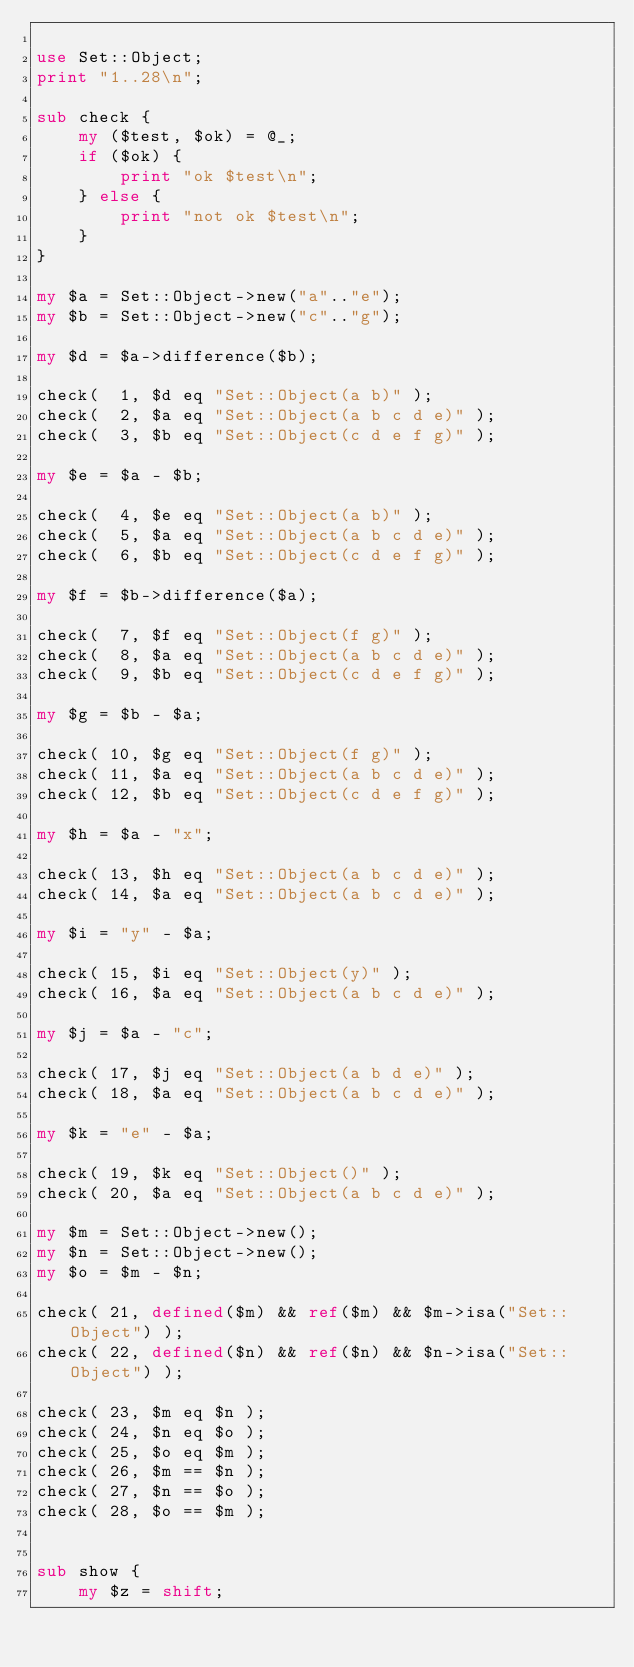Convert code to text. <code><loc_0><loc_0><loc_500><loc_500><_Perl_>
use Set::Object;
print "1..28\n";

sub check {
    my ($test, $ok) = @_;
    if ($ok) {
        print "ok $test\n";
    } else {
        print "not ok $test\n";
    }
}

my $a = Set::Object->new("a".."e");
my $b = Set::Object->new("c".."g");

my $d = $a->difference($b);

check(  1, $d eq "Set::Object(a b)" );
check(  2, $a eq "Set::Object(a b c d e)" );
check(  3, $b eq "Set::Object(c d e f g)" );

my $e = $a - $b;

check(  4, $e eq "Set::Object(a b)" );
check(  5, $a eq "Set::Object(a b c d e)" );
check(  6, $b eq "Set::Object(c d e f g)" );

my $f = $b->difference($a);

check(  7, $f eq "Set::Object(f g)" );
check(  8, $a eq "Set::Object(a b c d e)" );
check(  9, $b eq "Set::Object(c d e f g)" );

my $g = $b - $a;

check( 10, $g eq "Set::Object(f g)" );
check( 11, $a eq "Set::Object(a b c d e)" );
check( 12, $b eq "Set::Object(c d e f g)" );

my $h = $a - "x";

check( 13, $h eq "Set::Object(a b c d e)" );
check( 14, $a eq "Set::Object(a b c d e)" );

my $i = "y" - $a;

check( 15, $i eq "Set::Object(y)" );
check( 16, $a eq "Set::Object(a b c d e)" );

my $j = $a - "c";

check( 17, $j eq "Set::Object(a b d e)" );
check( 18, $a eq "Set::Object(a b c d e)" );

my $k = "e" - $a;

check( 19, $k eq "Set::Object()" );
check( 20, $a eq "Set::Object(a b c d e)" );

my $m = Set::Object->new();
my $n = Set::Object->new();
my $o = $m - $n;

check( 21, defined($m) && ref($m) && $m->isa("Set::Object") );
check( 22, defined($n) && ref($n) && $n->isa("Set::Object") );

check( 23, $m eq $n );
check( 24, $n eq $o );
check( 25, $o eq $m );
check( 26, $m == $n );
check( 27, $n == $o );
check( 28, $o == $m );


sub show {
    my $z = shift;
</code> 